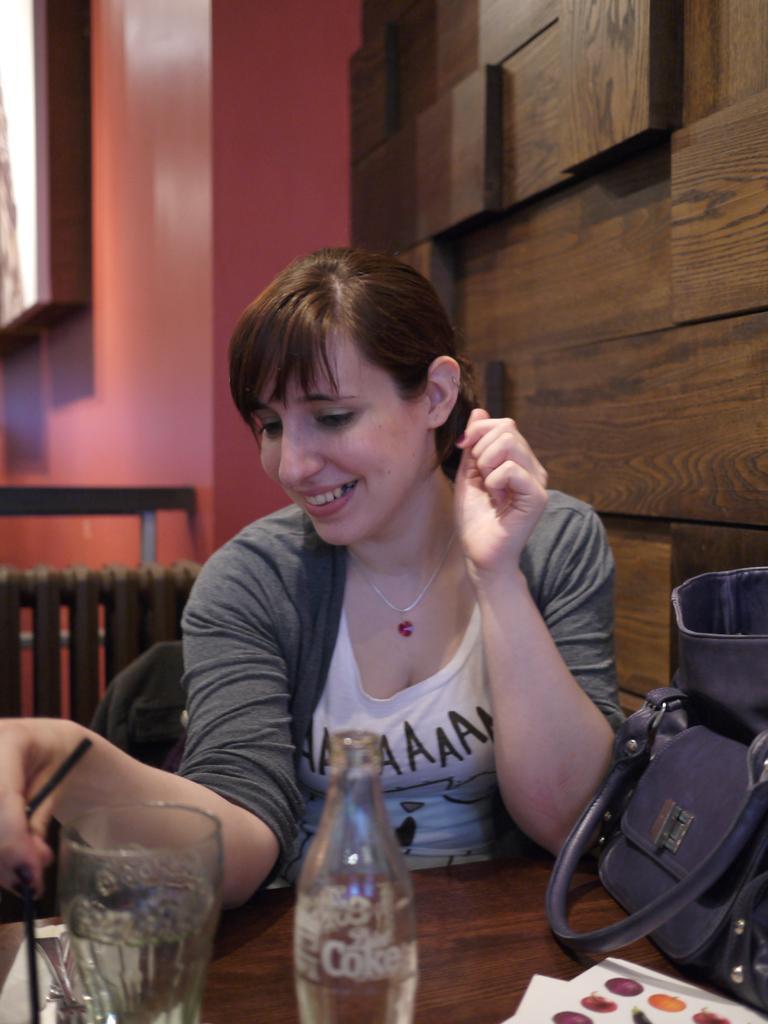Could you give a brief overview of what you see in this image? In this image I see a woman who is sitting on the chair and she is smiling. I can see the table on which there is a glass, a bottle and a bag, I can also see that she is holding a straw. In the background I see the wall. 